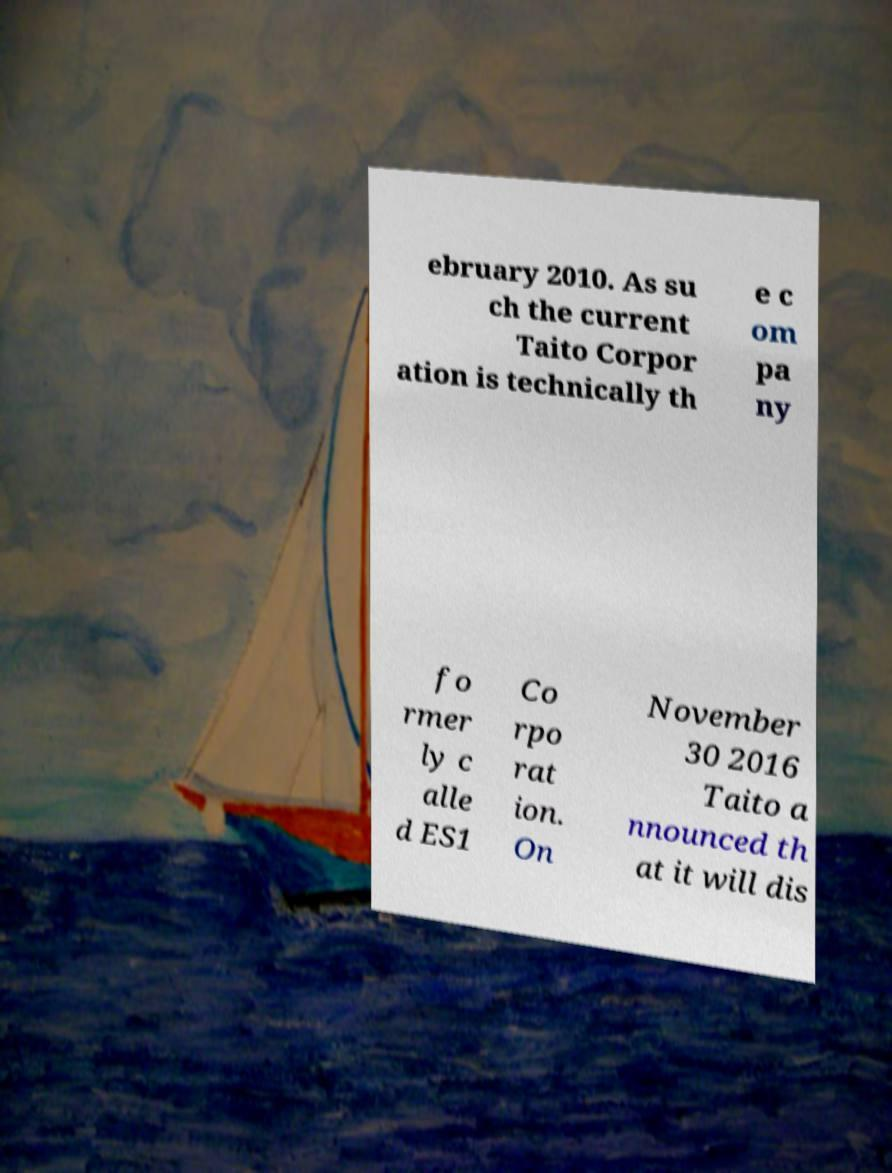Could you extract and type out the text from this image? ebruary 2010. As su ch the current Taito Corpor ation is technically th e c om pa ny fo rmer ly c alle d ES1 Co rpo rat ion. On November 30 2016 Taito a nnounced th at it will dis 